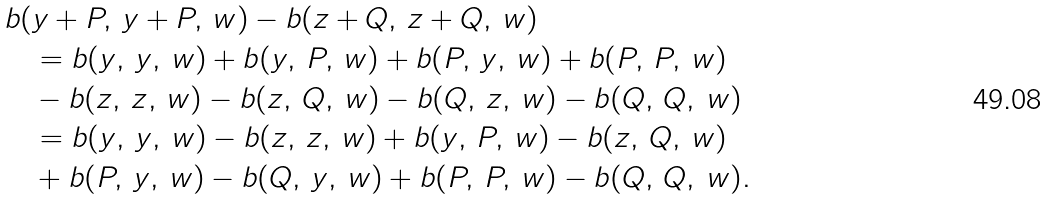<formula> <loc_0><loc_0><loc_500><loc_500>& b ( y + P , \, y + P , \, w ) - b ( z + Q , \, z + Q , \, w ) \\ & \quad = b ( y , \, y , \, w ) + b ( y , \, P , \, w ) + b ( P , \, y , \, w ) + b ( P , \, P , \, w ) \\ & \quad - b ( z , \, z , \, w ) - b ( z , \, Q , \, w ) - b ( Q , \, z , \, w ) - b ( Q , \, Q , \, w ) \\ & \quad = b ( y , \, y , \, w ) - b ( z , \, z , \, w ) + b ( y , \, P , \, w ) - b ( z , \, Q , \, w ) \\ & \quad + b ( P , \, y , \, w ) - b ( Q , \, y , \, w ) + b ( P , \, P , \, w ) - b ( Q , \, Q , \, w ) .</formula> 